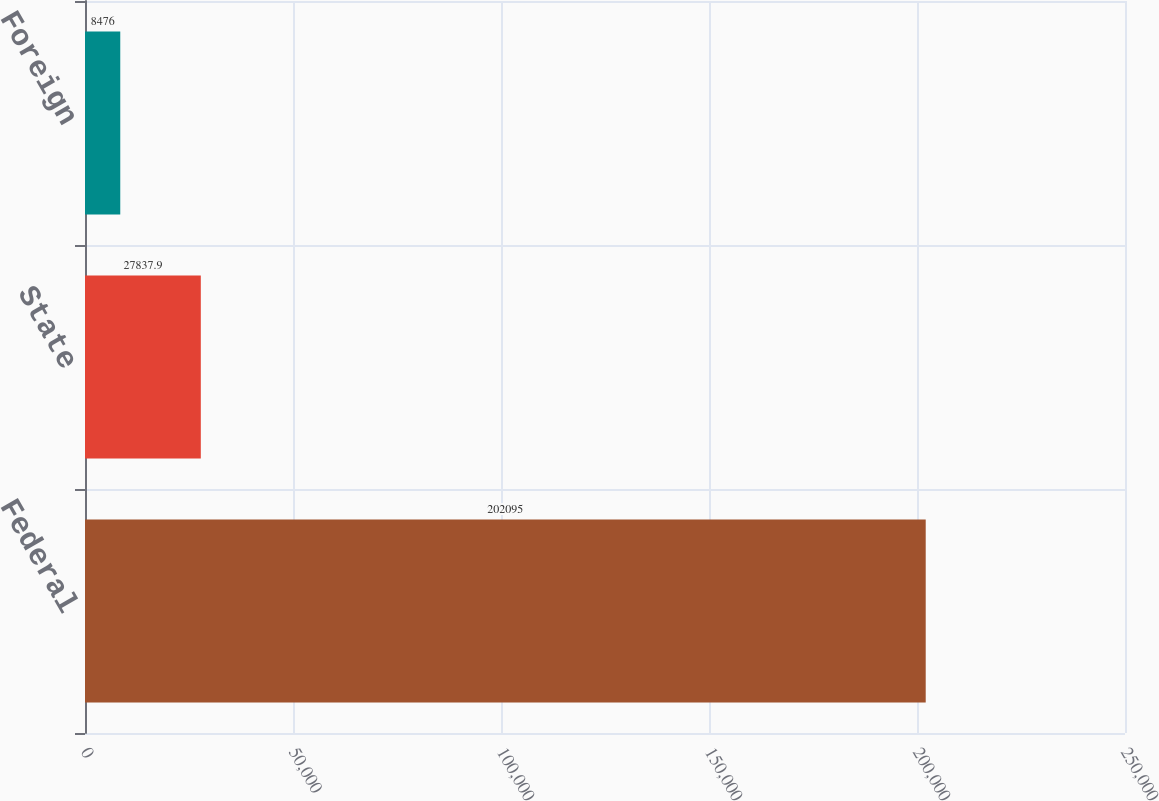Convert chart. <chart><loc_0><loc_0><loc_500><loc_500><bar_chart><fcel>Federal<fcel>State<fcel>Foreign<nl><fcel>202095<fcel>27837.9<fcel>8476<nl></chart> 